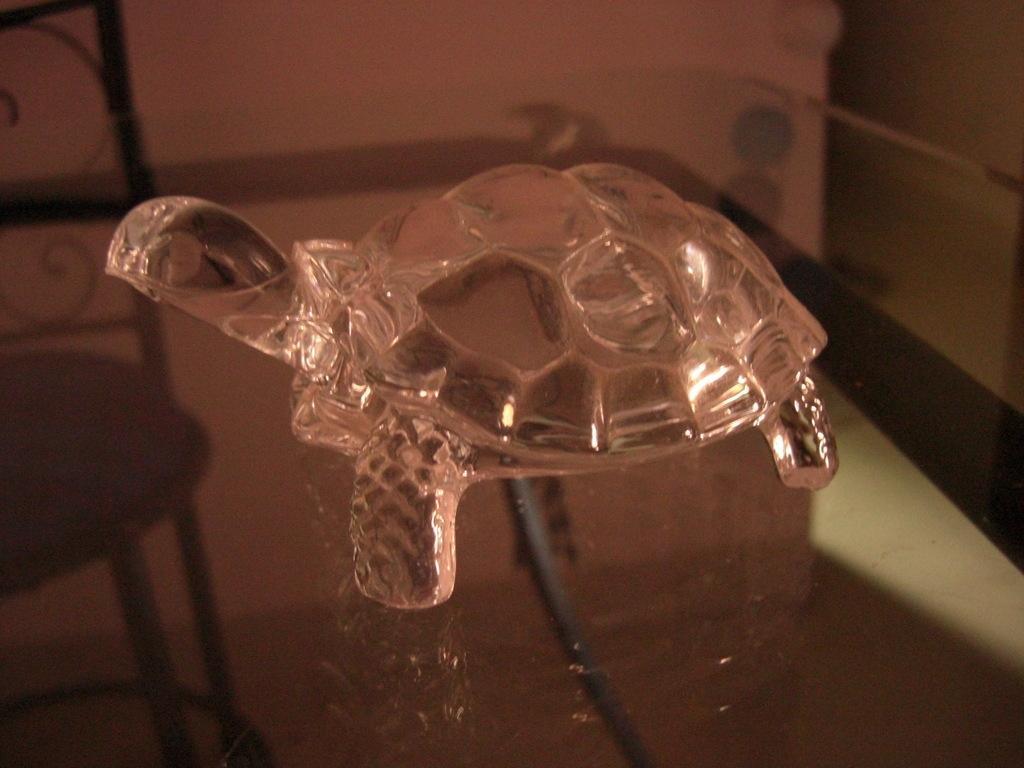Could you give a brief overview of what you see in this image? In this picture there is a model of tortoise in the center of the image, on a table. 